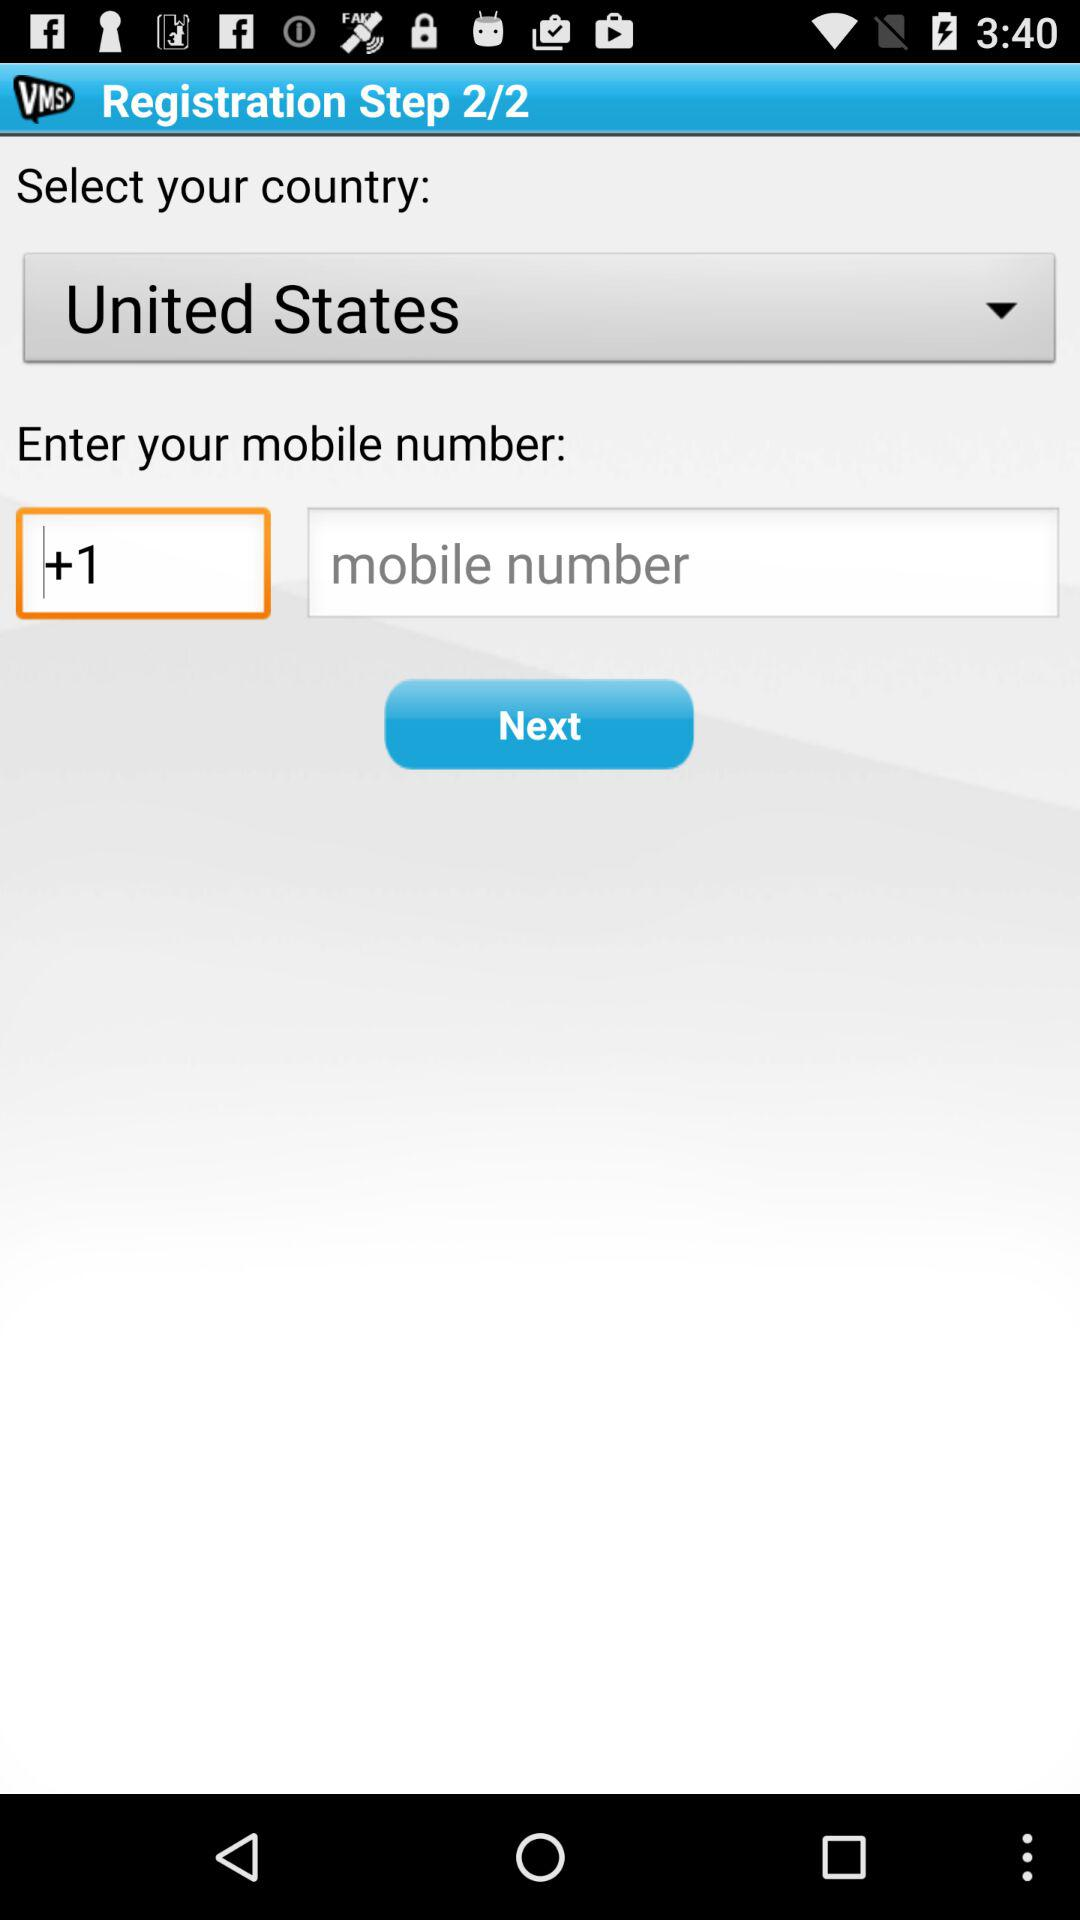What is the name of the country? The name of the country is the United States. 